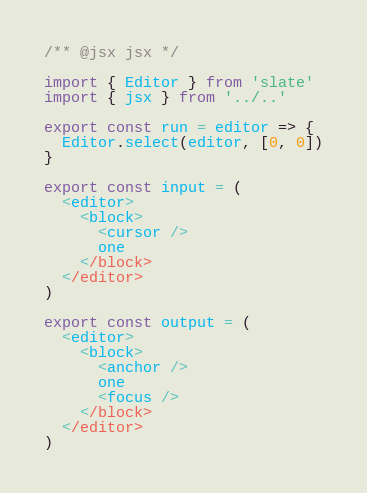<code> <loc_0><loc_0><loc_500><loc_500><_JavaScript_>/** @jsx jsx */

import { Editor } from 'slate'
import { jsx } from '../..'

export const run = editor => {
  Editor.select(editor, [0, 0])
}

export const input = (
  <editor>
    <block>
      <cursor />
      one
    </block>
  </editor>
)

export const output = (
  <editor>
    <block>
      <anchor />
      one
      <focus />
    </block>
  </editor>
)
</code> 